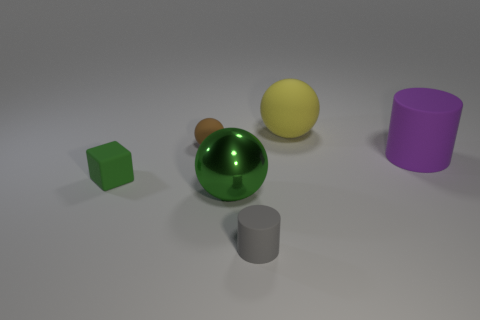How many objects are either brown spheres or big purple matte cylinders? In the image, there appears to be one brown sphere and one large purple matte cylinder. Thus, there are a total of two objects that fit the described criteria. 